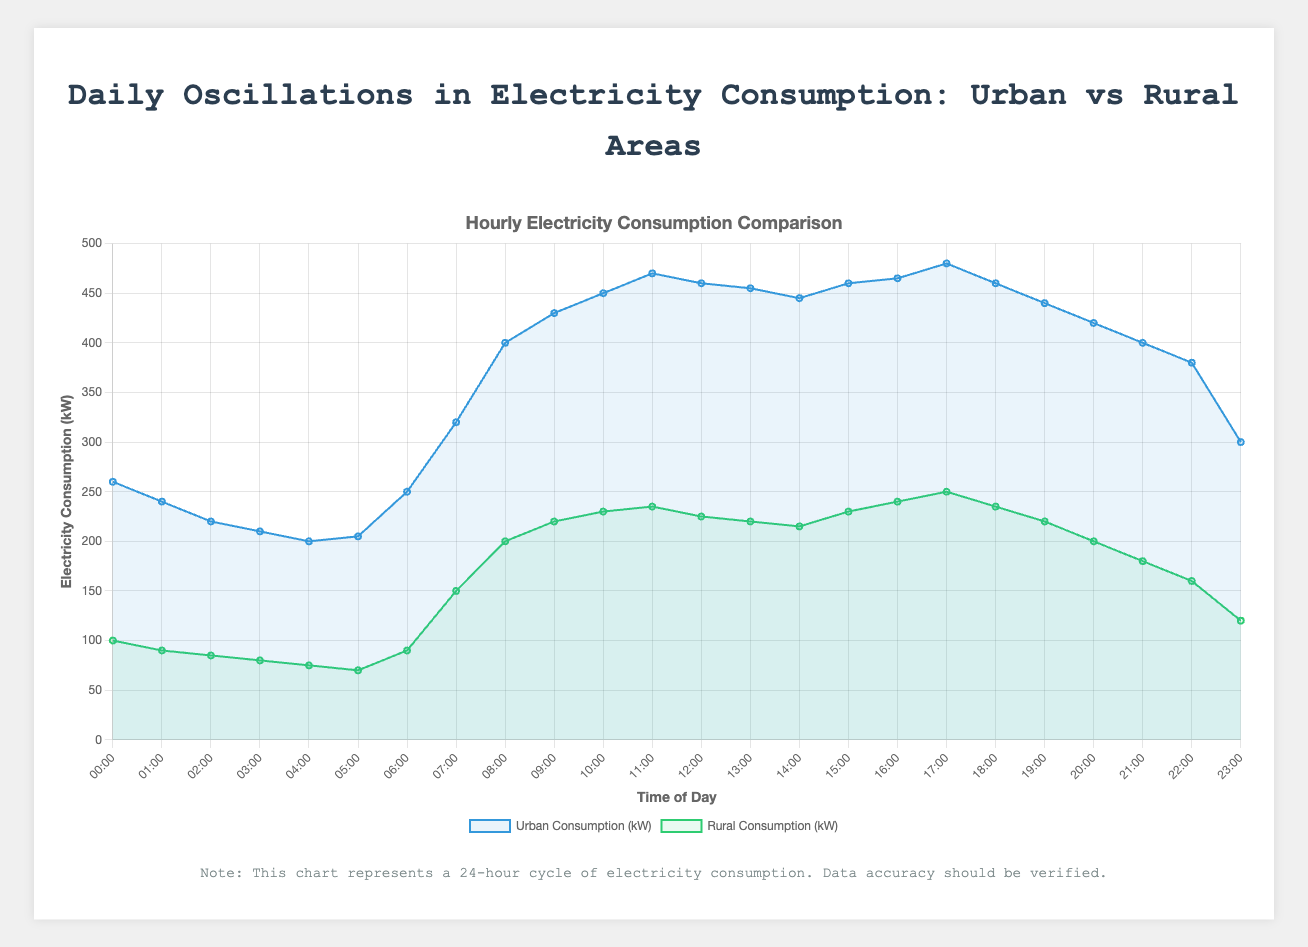What is the time with the maximum electricity consumption in urban areas? To find the maximum electricity consumption in urban areas, look at the urban consumption curve and identify the peak. The peak occurs at 17:00 with a value of 480 kW.
Answer: 17:00 What are the minimum electricity consumption values for urban and rural areas, respectively? Observing the curves, the lowest point for urban consumption is 200 kW at 04:00. For rural areas, the lowest point is 70 kW at 05:00.
Answer: 200 kW (urban), 70 kW (rural) During which hours does rural electricity consumption surpass urban electricity consumption? Comparing the curves for both areas, rural consumption never surpasses urban consumption at any hour.
Answer: Never By how much does urban consumption at 08:00 exceed rural consumption at the same time? At 08:00, urban consumption is 400 kW while rural consumption is 200 kW. The difference is 400 - 200 = 200 kW.
Answer: 200 kW What is the average electricity consumption between 12:00 and 18:00 for urban areas? The values for urban consumption from 12:00 to 18:00 are 460, 455, 445, 460, 465, 480. Calculate the average by summing these values and dividing by 6: (460 + 455 + 445 + 460 + 465 + 480) / 6 = 2765 / 6 ≈ 461 kW.
Answer: 461 kW Which area has a more significant increase in consumption from 06:00 to 09:00, urban or rural? Urban consumption goes from 250 kW to 430 kW, an increase of 430 - 250 = 180 kW. Rural consumption goes from 90 kW to 220 kW, an increase of 220 - 90 = 130 kW. Urban consumption has the more significant increase.
Answer: Urban At what time is the consumption difference between urban and rural areas the greatest? Identify the times when the difference is at its highest. The peak difference occurs at 17:00 with urban at 480 kW and rural at 250 kW. The difference is 480 - 250 = 230 kW.
Answer: 17:00 How does the consumption change in urban areas from 21:00 to 23:00? Between 21:00 (400 kW) and 23:00 (300 kW), urban consumption decreases by 400 - 300 = 100 kW.
Answer: Decreases by 100 kW 